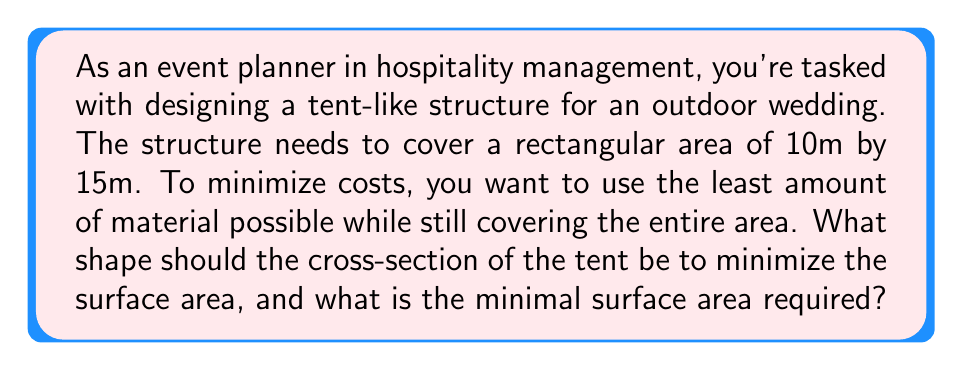Can you answer this question? To solve this problem, we'll use concepts from differential geometry and calculus of variations. The shape that minimizes the surface area while covering a given base is called a minimal surface.

Step 1: Recognize that the cross-section of the tent will be a catenary curve, which is the shape formed by a chain or rope hanging under its own weight.

Step 2: The equation of a catenary curve is given by:

$$y = a \cosh(\frac{x}{a})$$

where $a$ is a constant that determines the shape of the curve.

Step 3: We need to find the value of $a$ that minimizes the surface area. The surface area of the tent is given by:

$$S = 2L \int_0^{w/2} \sqrt{1 + (\frac{dy}{dx})^2} dx$$

where $L$ is the length of the tent (15m) and $w$ is the width (10m).

Step 4: Substituting the catenary equation and its derivative:

$$S = 2L \int_0^{w/2} \sqrt{1 + \sinh^2(\frac{x}{a})} dx = 2La \sinh(\frac{w}{2a})$$

Step 5: The height of the tent at the center is given by:

$$h = a(\cosh(\frac{w}{2a}) - 1)$$

Step 6: To minimize the surface area, we need to find the value of $a$ that satisfies:

$$\frac{dS}{da} = 0$$

This leads to the equation:

$$\frac{w}{2a} = \tanh(\frac{w}{2a})$$

Step 7: Solving this equation numerically (e.g., using Newton's method), we find:

$$\frac{w}{2a} \approx 1.19968$$

For $w = 10m$, this gives $a \approx 4.16811m$.

Step 8: Calculate the minimal surface area:

$$S = 2 \cdot 15 \cdot 4.16811 \cdot \sinh(1.19968) \approx 164.85m^2$$
Answer: Catenary cross-section with $a \approx 4.16811m$; minimal surface area $\approx 164.85m^2$ 